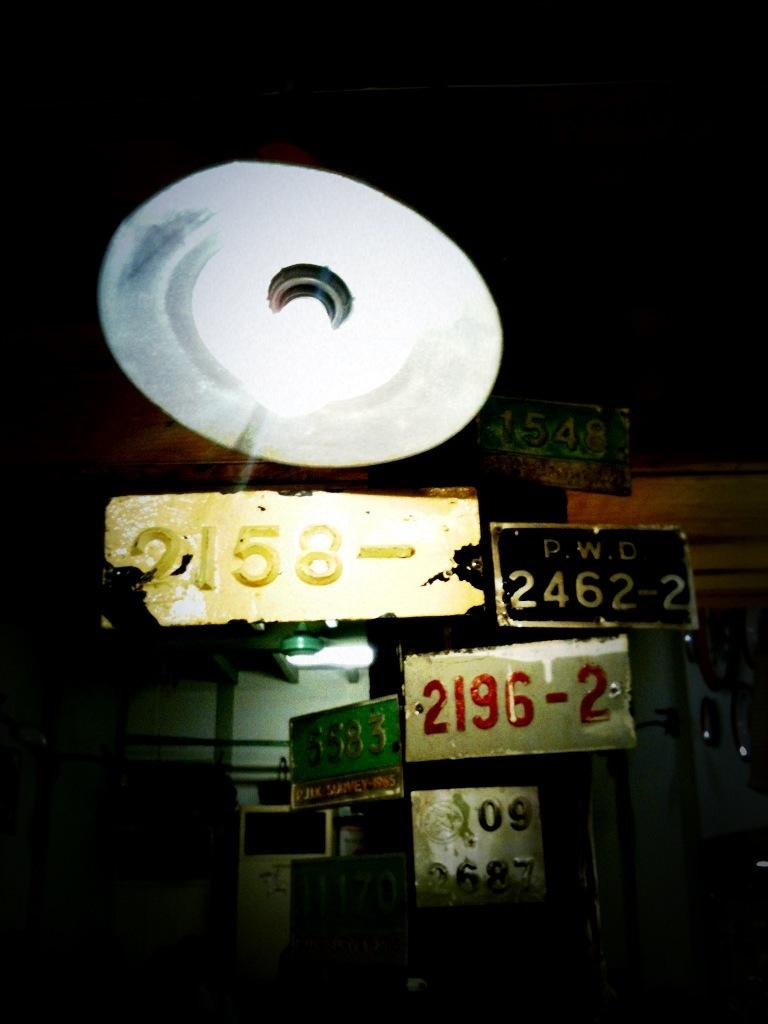<image>
Create a compact narrative representing the image presented. Several different license plates, including one from P.W.D, hang under a light. 